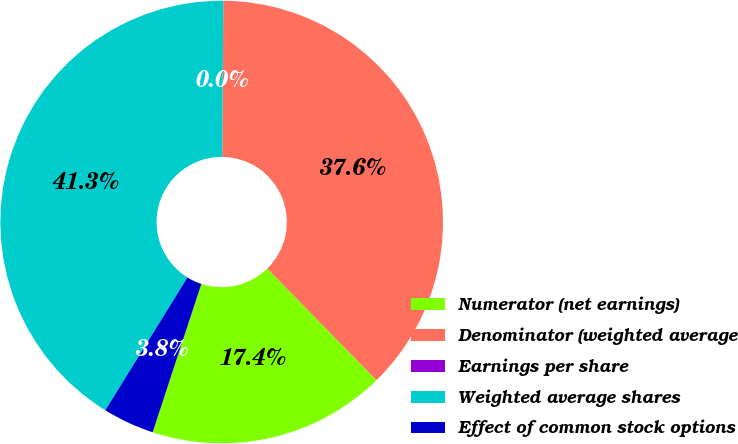Convert chart. <chart><loc_0><loc_0><loc_500><loc_500><pie_chart><fcel>Numerator (net earnings)<fcel>Denominator (weighted average<fcel>Earnings per share<fcel>Weighted average shares<fcel>Effect of common stock options<nl><fcel>17.38%<fcel>37.56%<fcel>0.0%<fcel>41.31%<fcel>3.76%<nl></chart> 